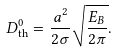<formula> <loc_0><loc_0><loc_500><loc_500>D _ { \text {th} } ^ { 0 } = \frac { a ^ { 2 } } { 2 \sigma } \sqrt { \frac { E _ { B } } { 2 \pi } } .</formula> 